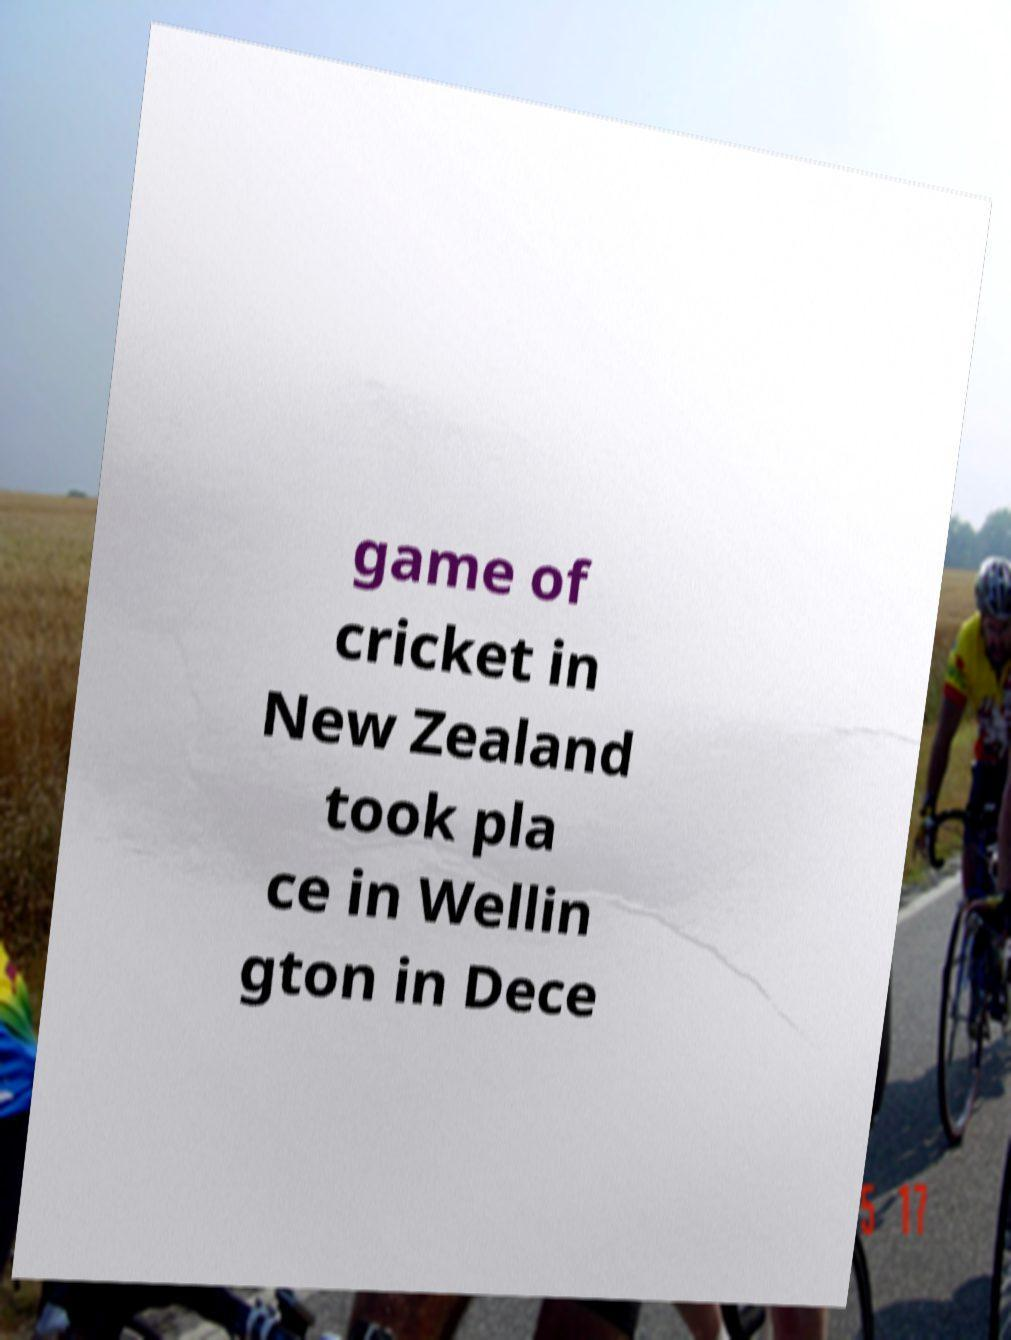For documentation purposes, I need the text within this image transcribed. Could you provide that? game of cricket in New Zealand took pla ce in Wellin gton in Dece 